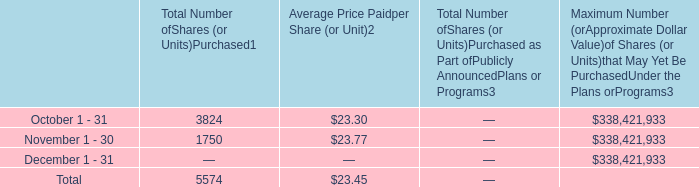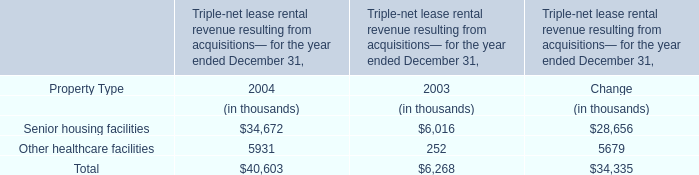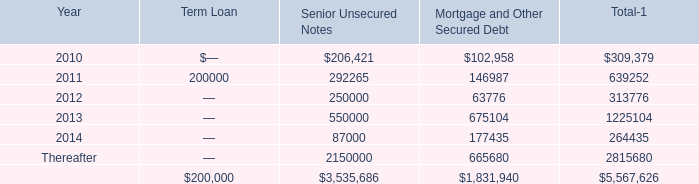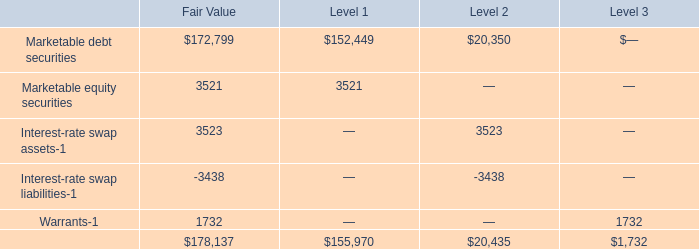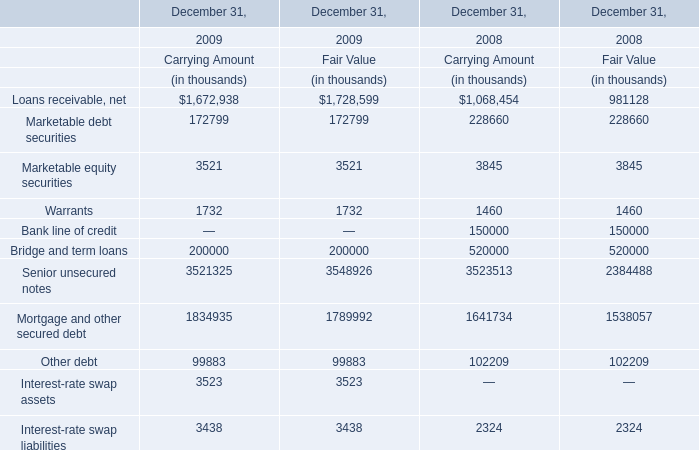In the year with smaller amount of Bridge and term loans at Fair Value, what's the value of Other debt at Fair Value? (in thousand) 
Answer: 99883. 